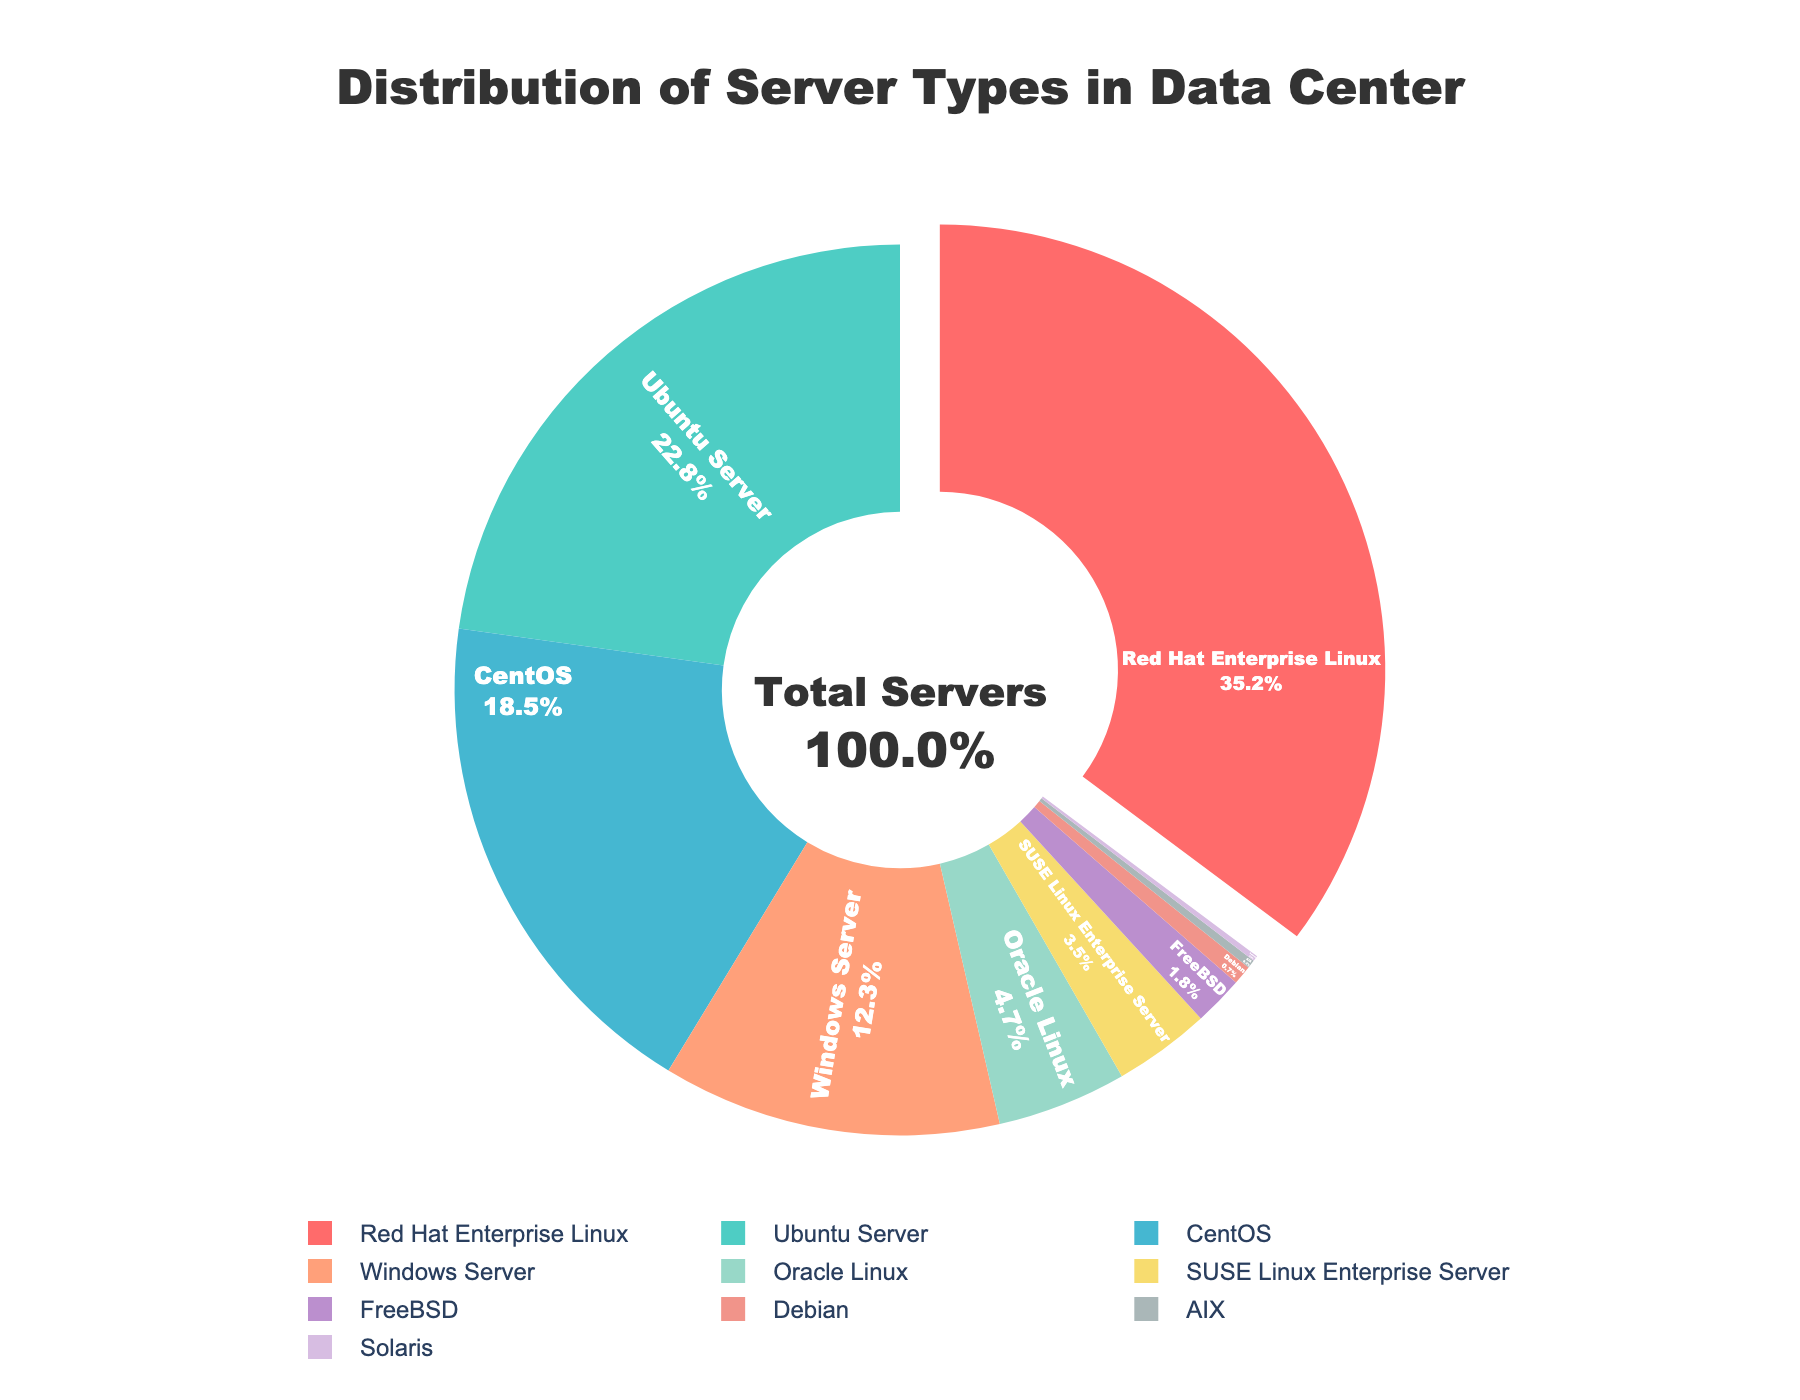What percentage of servers run on Red Hat Enterprise Linux? The figure shows that Red Hat Enterprise Linux has the largest slice of the pie chart. Referring to the label, Red Hat Enterprise Linux servers make up 35.2% of the total servers.
Answer: 35.2% Which server type has the smallest share? By observing the sizes of the slices in the pie chart, the smallest slice corresponds to the Solaris server type. Referring to its label, Solaris servers make up 0.2% of the total servers.
Answer: Solaris What is the combined percentage of Ubuntu Server and CentOS servers? Sum the percentages of Ubuntu Server and CentOS by referring to the figure: 22.8% (Ubuntu Server) + 18.5% (CentOS) equals 41.3%.
Answer: 41.3% How much larger is the percentage of Red Hat Enterprise Linux servers compared to Windows Server? Subtract the Windows Server percentage from the Red Hat Enterprise Linux percentage. Red Hat Enterprise Linux is 35.2% and Windows Server is 12.3%, so the difference is 35.2% - 12.3% = 22.9%.
Answer: 22.9% Which three server types have the largest shares and what is their combined percentage? The three largest slices are for Red Hat Enterprise Linux, Ubuntu Server, and CentOS, based on their sizes in the pie chart. Adding their percentages: 35.2% (Red Hat Enterprise Linux) + 22.8% (Ubuntu Server) + 18.5% (CentOS) equals 76.5%.
Answer: Red Hat Enterprise Linux, Ubuntu Server, CentOS; 76.5% Which server type has a larger share, SUSE Linux Enterprise Server or Oracle Linux? Comparing the slices for SUSE Linux Enterprise Server and Oracle Linux, Oracle Linux has a larger share. Referring to their labels, Oracle Linux is 4.7%, and SUSE Linux Enterprise Server is 3.5%.
Answer: Oracle Linux What is the total percentage of servers that run on Unix-based systems (including Linux and UNIX flavors)? Sum the percentages of all Linux and Unix-based server types: 35.2% (Red Hat Enterprise Linux) + 22.8% (Ubuntu Server) + 18.5% (CentOS) + 4.7% (Oracle Linux) + 3.5% (SUSE Linux Enterprise Server) + 1.8% (FreeBSD) + 0.7% (Debian) + 0.3% (AIX) + 0.2% (Solaris). The total is 87.7%.
Answer: 87.7% Is the number of servers using Red Hat Enterprise Linux more than twice the number of servers using Windows Server? Compare twice the percentage of Windows Server to the percentage of Red Hat Enterprise Linux. Twice the percentage of Windows Server is 12.3% * 2 = 24.6%, which is less than 35.2% for Red Hat Enterprise Linux.
Answer: Yes Which server types have over 20% share? The slices of the pie chart over 20% are for Red Hat Enterprise Linux and Ubuntu Server. Referring to their labels, Red Hat Enterprise Linux is 35.2%, and Ubuntu Server is 22.8%.
Answer: Red Hat Enterprise Linux, Ubuntu Server 